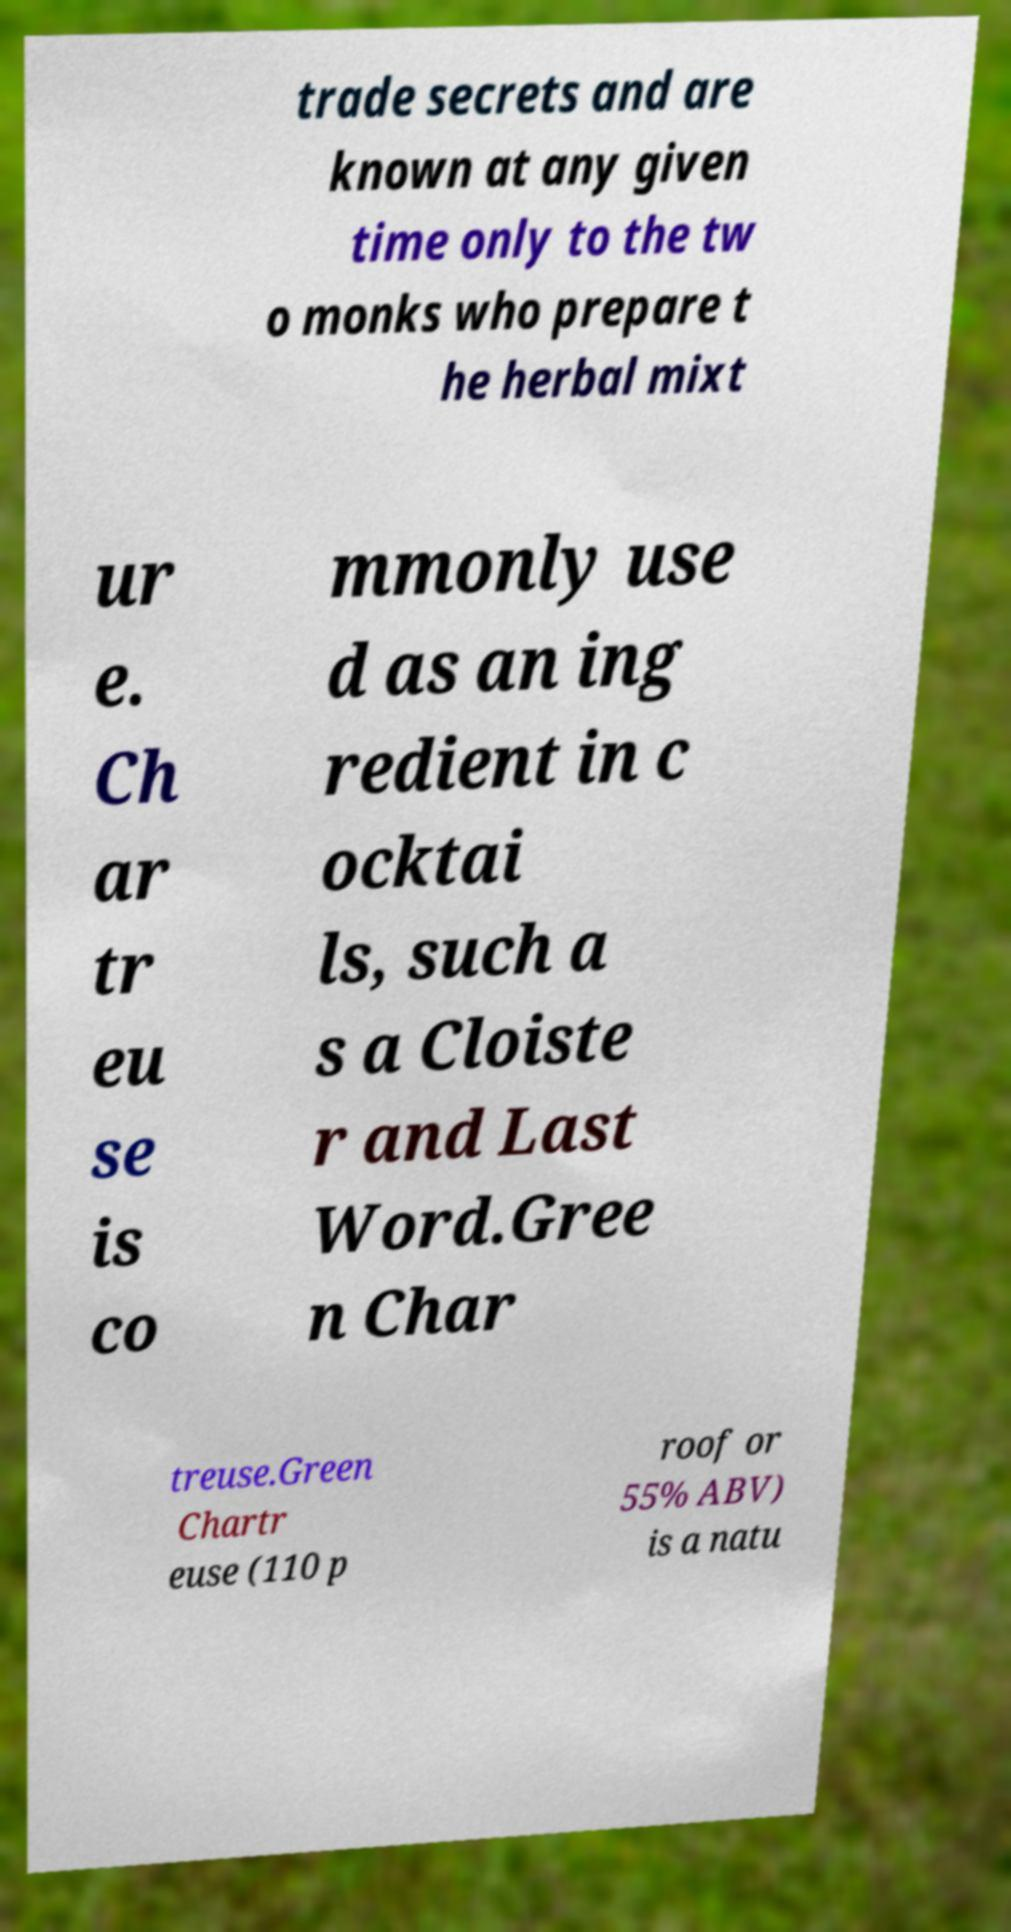Can you read and provide the text displayed in the image?This photo seems to have some interesting text. Can you extract and type it out for me? trade secrets and are known at any given time only to the tw o monks who prepare t he herbal mixt ur e. Ch ar tr eu se is co mmonly use d as an ing redient in c ocktai ls, such a s a Cloiste r and Last Word.Gree n Char treuse.Green Chartr euse (110 p roof or 55% ABV) is a natu 